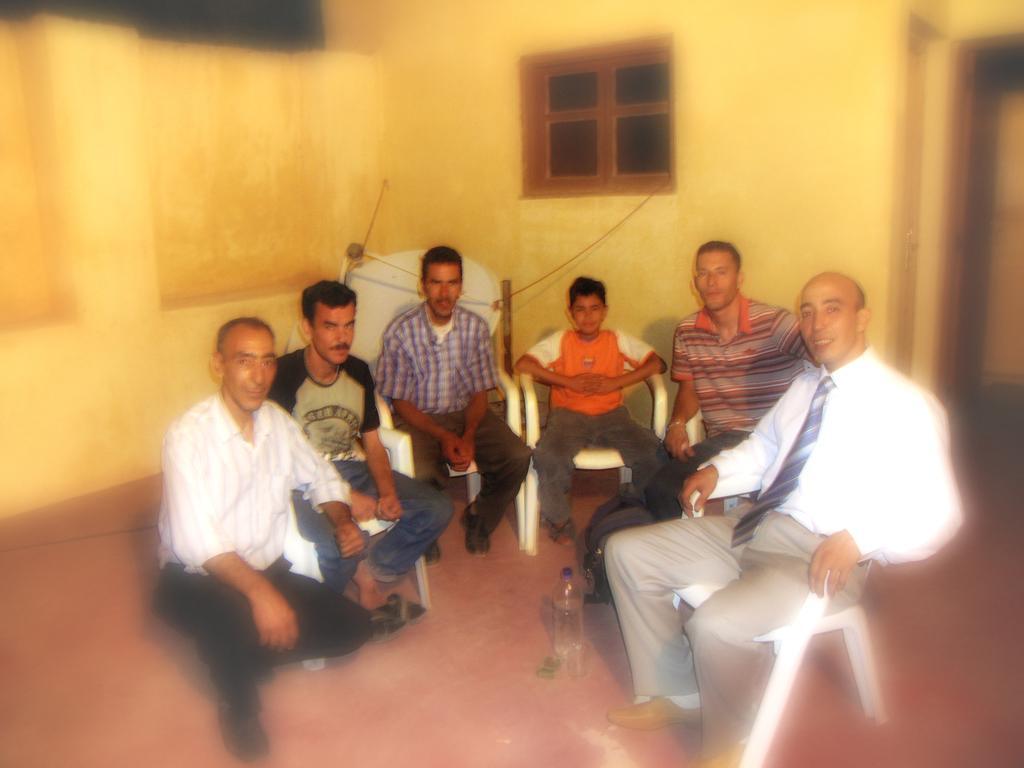Can you describe this image briefly? In this image we can see men and a boy are sitting on the chairs. At the bottom of the image, we can see a bottle on the floor. In the background of the image, we can see a wall and a window. There is a door on the right side of the image. 